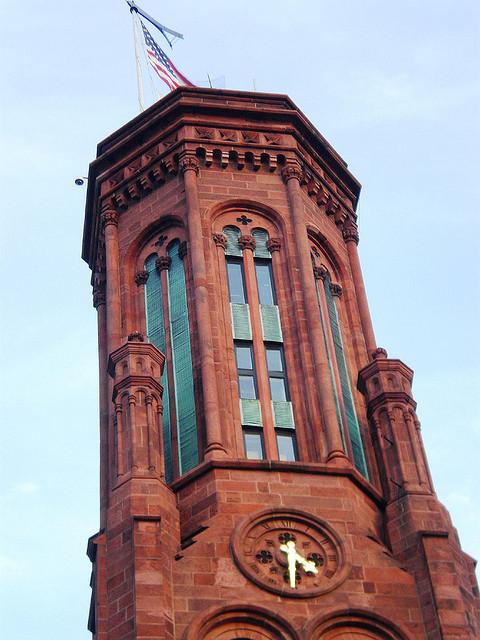Is this a church?
Write a very short answer. No. What time does the clock say?
Short answer required. 4:30. What is on top of the building?
Keep it brief. Flag. What time is it?
Short answer required. 4:30. Is this Big Ben?
Answer briefly. No. What is on top of the tower?
Short answer required. Flag. 